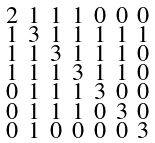<formula> <loc_0><loc_0><loc_500><loc_500>\begin{smallmatrix} 2 & 1 & 1 & 1 & 0 & 0 & 0 \\ 1 & 3 & 1 & 1 & 1 & 1 & 1 \\ 1 & 1 & 3 & 1 & 1 & 1 & 0 \\ 1 & 1 & 1 & 3 & 1 & 1 & 0 \\ 0 & 1 & 1 & 1 & 3 & 0 & 0 \\ 0 & 1 & 1 & 1 & 0 & 3 & 0 \\ 0 & 1 & 0 & 0 & 0 & 0 & 3 \end{smallmatrix}</formula> 